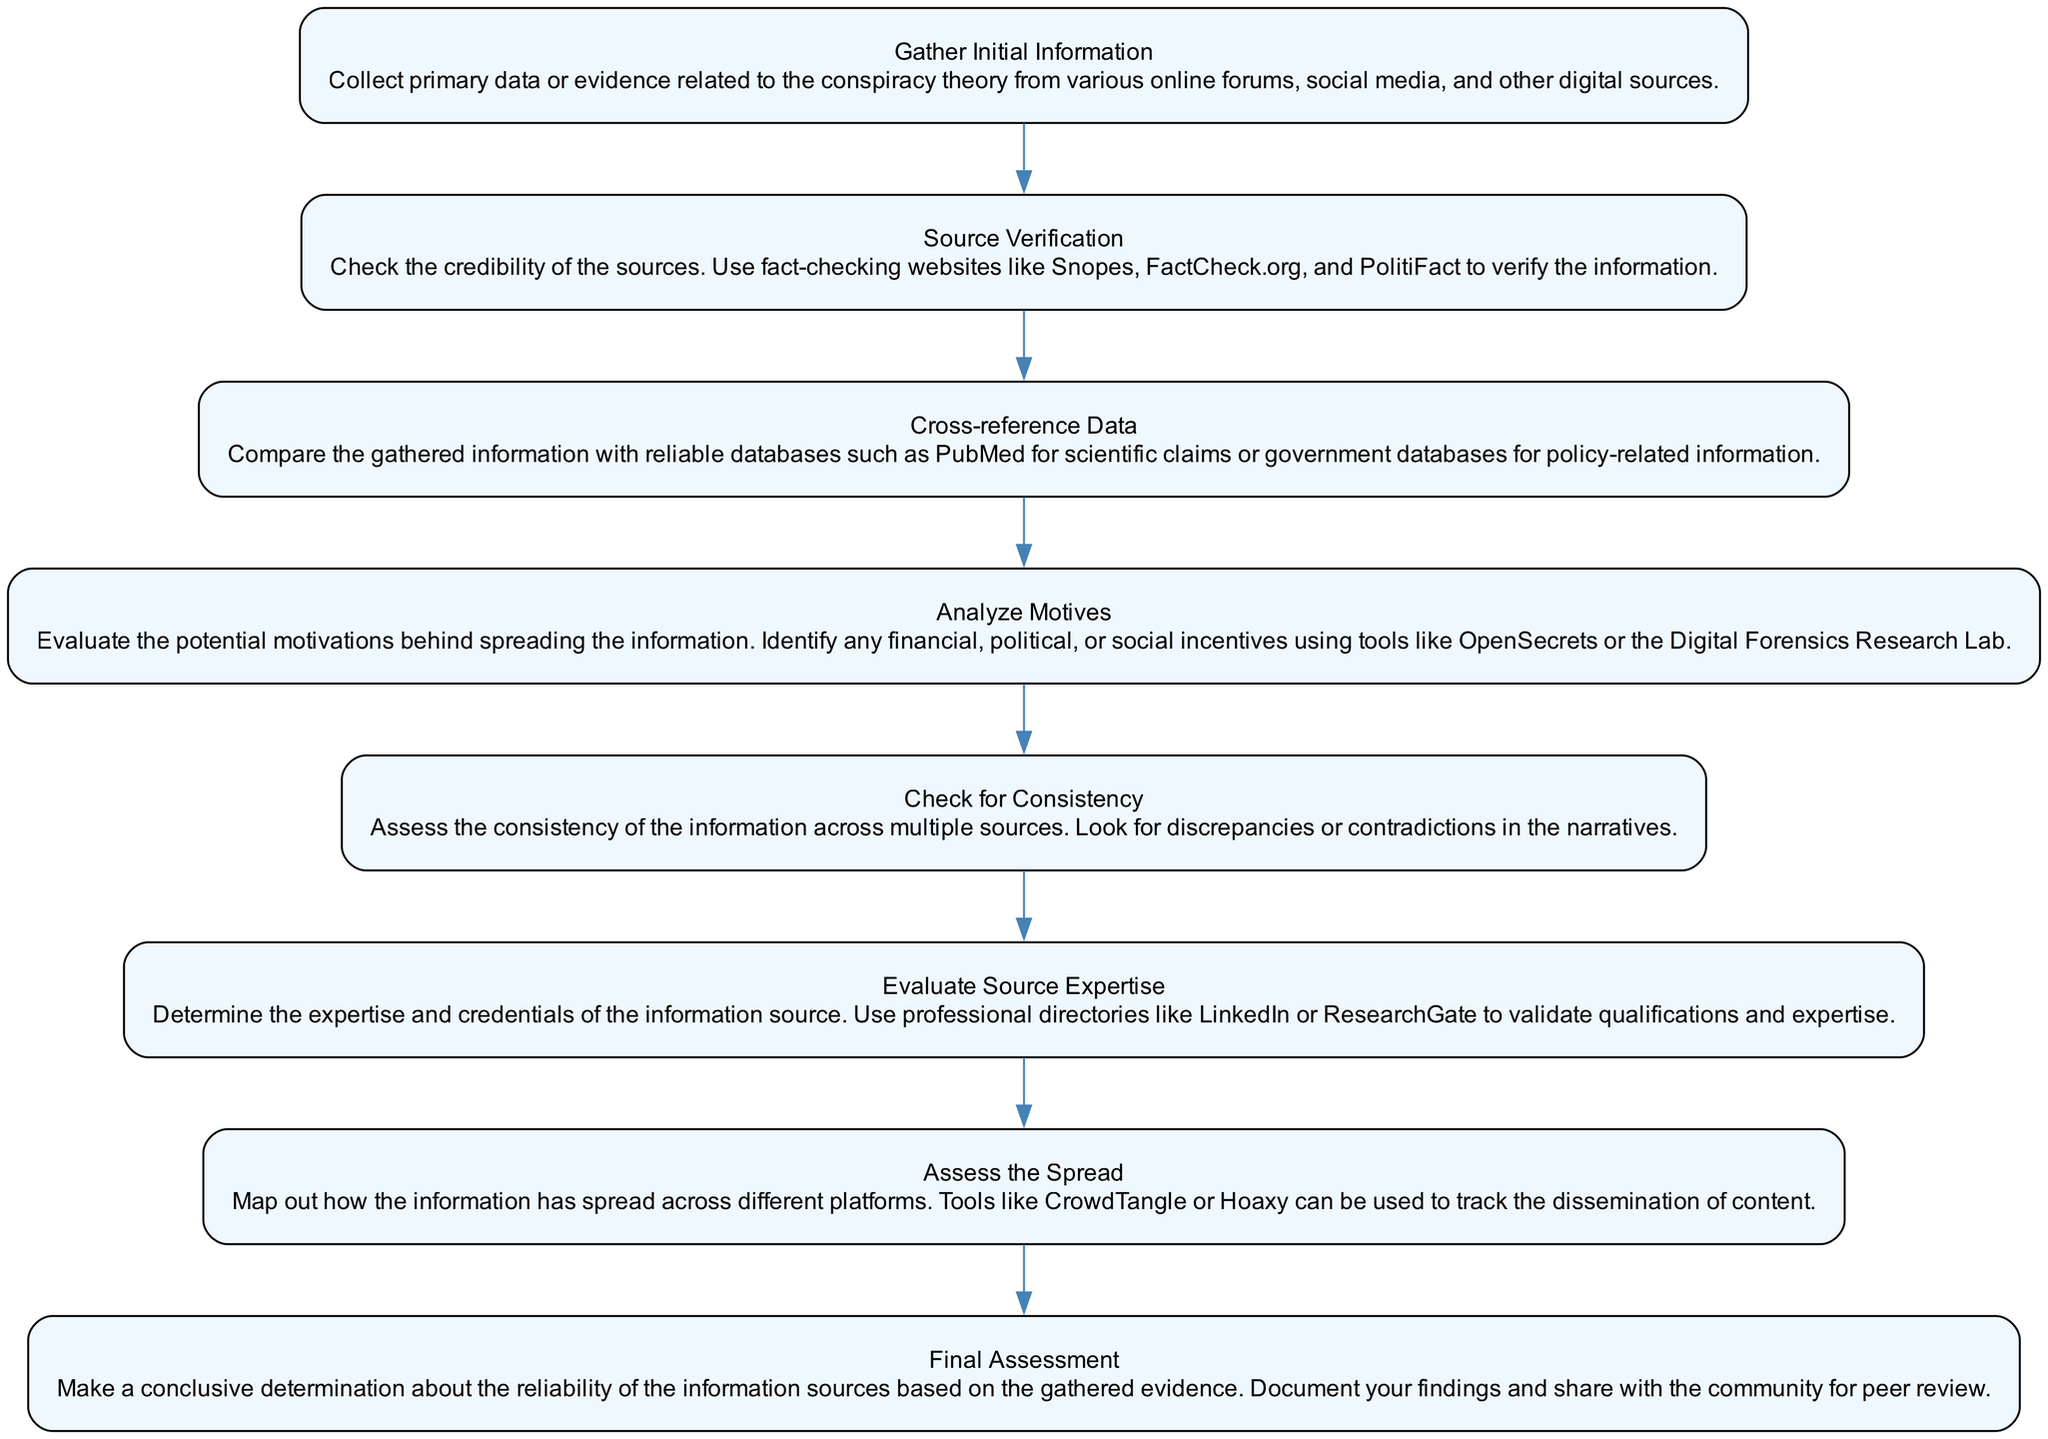What is the first step in the process? The first step in the process is "Gather Initial Information." This is indicated as the starting node in the flowchart, leading into the subsequent steps.
Answer: Gather Initial Information How many nodes are in the flowchart? By counting all the steps listed in the flowchart, we find there are eight nodes representing each distinct stage of the process.
Answer: 8 What follows "Source Verification"? The node that directly follows "Source Verification" in the flowchart is "Cross-reference Data," as there is a direct edge connecting these two steps.
Answer: Cross-reference Data Which step evaluates potential motivations behind the information? The step that specifically evaluates the motivations is "Analyze Motives." This node addresses the reasons why certain information might be disseminated.
Answer: Analyze Motives What is the last step of the flowchart? The final step of the flowchart is "Final Assessment." This conclusion summarizes and documents the findings from all previous steps.
Answer: Final Assessment How do you assess the spread of information? The flowchart indicates that the assessment of the spread is done in the "Assess the Spread" step, which involves mapping out how information has circulated across different platforms.
Answer: Assess the Spread Which two steps are directly connected to “Cross-reference Data”? The "Cross-reference Data" step is directly connected to "Source Verification" before it and to "Analyze Motives" after it, forming a sequential flow.
Answer: Source Verification, Analyze Motives What is the purpose of using tools like OpenSecrets in the process? OpenSecrets is used during the "Analyze Motives" step to identify any financial, political, or social incentives behind the information being analyzed.
Answer: Analyze Motives Which nodes focus on verifying credibility? The nodes that focus on verifying credibility are "Source Verification" and "Evaluate Source Expertise," as both deal with assessing the reliability of information sources.
Answer: Source Verification, Evaluate Source Expertise 